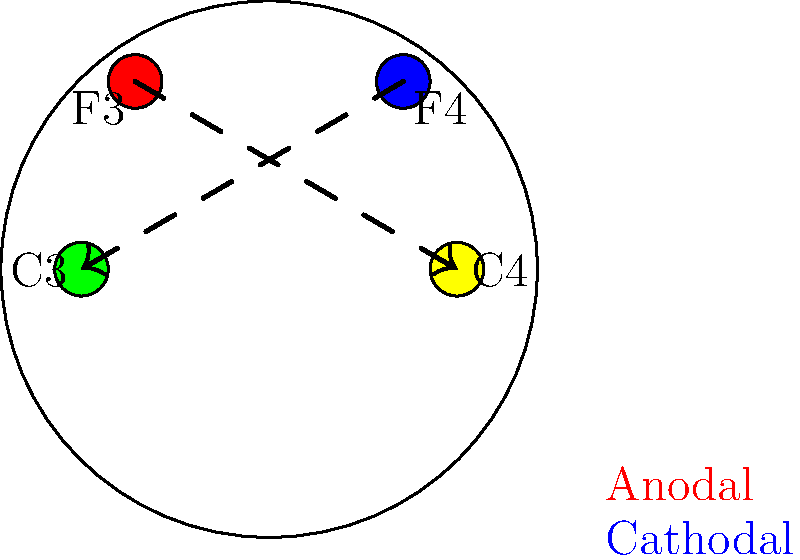Based on the electrode placements shown in the diagram, which tDCS montage is most likely to be effective in treating depression, and why? To answer this question, we need to consider the following steps:

1. Identify the electrode placements:
   - F3 (red): Left dorsolateral prefrontal cortex (DLPFC)
   - F4 (blue): Right DLPFC
   - C3 (green): Left motor cortex
   - C4 (yellow): Right motor cortex

2. Understand the typical tDCS montage for depression:
   - The most common and effective montage for depression involves anodal stimulation of the left DLPFC.

3. Analyze the current flow:
   - The diagram shows current flowing from F3 to C4 and from F4 to C3.

4. Consider the neurobiological basis of depression:
   - Depression is often associated with hypoactivity in the left DLPFC and hyperactivity in the right DLPFC.

5. Evaluate the montage effectiveness:
   - The F3-C4 montage (anodal at F3, cathodal at C4) is most likely to be effective because:
     a. It provides anodal (excitatory) stimulation to the left DLPFC (F3).
     b. The cathodal electrode is placed away from the right DLPFC, avoiding potential inhibition of this area.

6. Compare to alternative montages:
   - The F4-C3 montage is less likely to be effective because it stimulates the right DLPFC, which is often already hyperactive in depression.

Therefore, the F3-C4 montage (anodal at F3, cathodal at C4) is most likely to be effective in treating depression by enhancing activity in the left DLPFC, which is often underactive in depressed individuals.
Answer: F3-C4 montage (anodal at F3, cathodal at C4) 